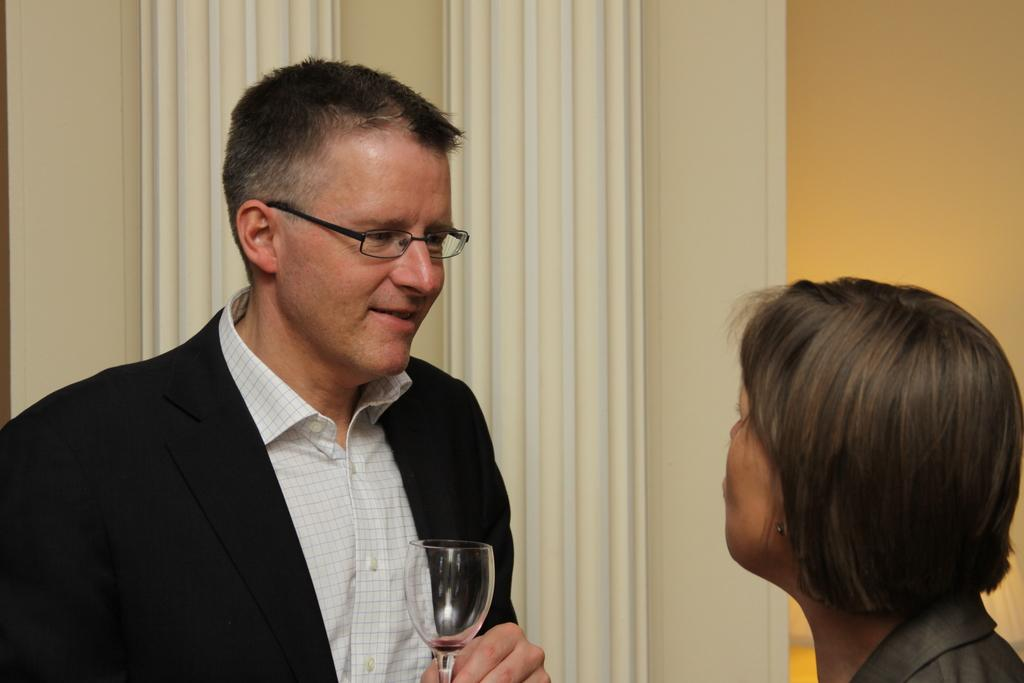How many people are in the image? There are people in the image, but the exact number is not specified. What are some of the people doing in the image? Some of the people are standing in the image. Can you describe any objects being held by the people? A man is holding a wine glass in his hand. What invention is the man demonstrating in the image? There is no invention being demonstrated in the image; the man is simply holding a wine glass. Can you see any badges on the people in the image? There is no mention of badges in the image, so it cannot be determined if any are present. 